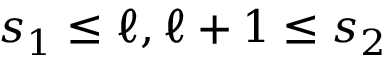Convert formula to latex. <formula><loc_0><loc_0><loc_500><loc_500>s _ { 1 } \leq \ell , \ell + 1 \leq s _ { 2 }</formula> 